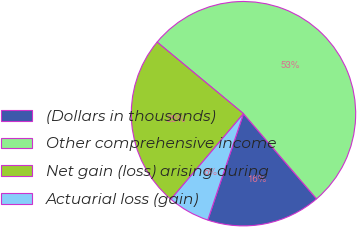Convert chart to OTSL. <chart><loc_0><loc_0><loc_500><loc_500><pie_chart><fcel>(Dollars in thousands)<fcel>Other comprehensive income<fcel>Net gain (loss) arising during<fcel>Actuarial loss (gain)<nl><fcel>16.44%<fcel>52.7%<fcel>24.83%<fcel>6.04%<nl></chart> 